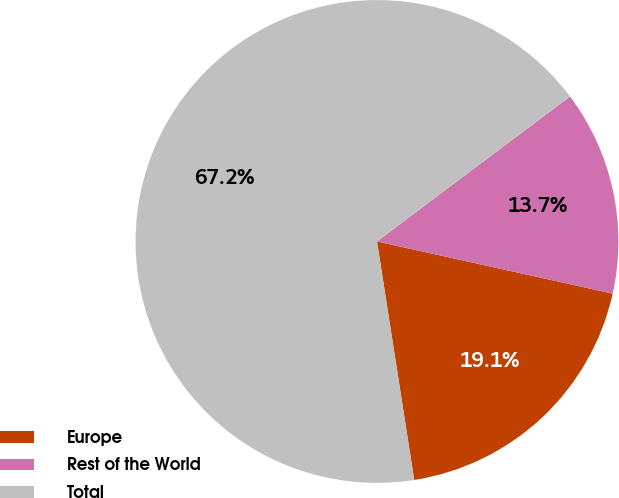<chart> <loc_0><loc_0><loc_500><loc_500><pie_chart><fcel>Europe<fcel>Rest of the World<fcel>Total<nl><fcel>19.07%<fcel>13.72%<fcel>67.22%<nl></chart> 